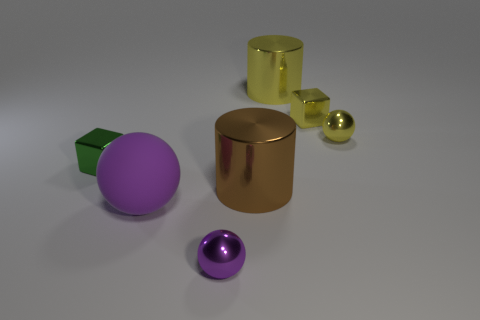Subtract all blue cylinders. How many purple spheres are left? 2 Subtract all tiny shiny balls. How many balls are left? 1 Add 2 tiny brown shiny spheres. How many objects exist? 9 Subtract all cubes. How many objects are left? 5 Subtract all big brown shiny things. Subtract all big brown metallic objects. How many objects are left? 5 Add 5 green metal blocks. How many green metal blocks are left? 6 Add 2 tiny green rubber balls. How many tiny green rubber balls exist? 2 Subtract 0 cyan cylinders. How many objects are left? 7 